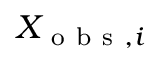<formula> <loc_0><loc_0><loc_500><loc_500>X _ { o b s , i }</formula> 